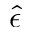Convert formula to latex. <formula><loc_0><loc_0><loc_500><loc_500>\hat { \epsilon }</formula> 